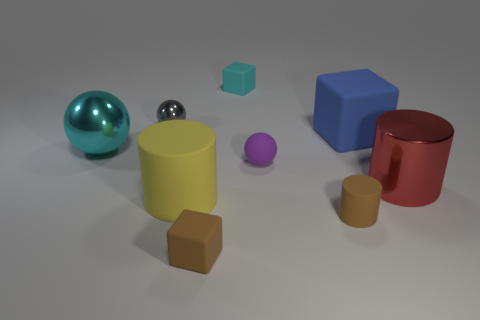Subtract all small cubes. How many cubes are left? 1 Subtract all brown cylinders. How many cylinders are left? 2 Add 2 green metal spheres. How many green metal spheres exist? 2 Subtract 0 blue cylinders. How many objects are left? 9 Subtract all cylinders. How many objects are left? 6 Subtract 3 cylinders. How many cylinders are left? 0 Subtract all brown cubes. Subtract all green spheres. How many cubes are left? 2 Subtract all cyan spheres. How many brown cylinders are left? 1 Subtract all small rubber objects. Subtract all gray metallic objects. How many objects are left? 4 Add 3 cyan shiny things. How many cyan shiny things are left? 4 